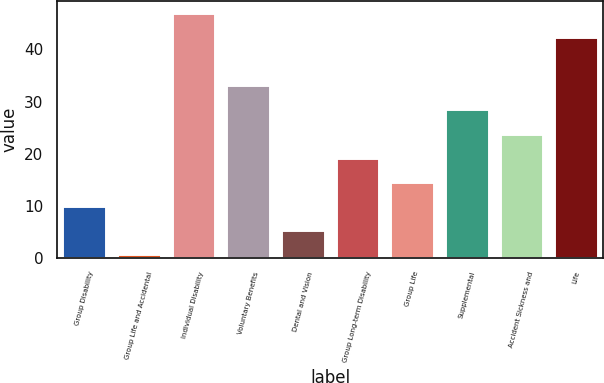Convert chart to OTSL. <chart><loc_0><loc_0><loc_500><loc_500><bar_chart><fcel>Group Disability<fcel>Group Life and Accidental<fcel>Individual Disability<fcel>Voluntary Benefits<fcel>Dental and Vision<fcel>Group Long-term Disability<fcel>Group Life<fcel>Supplemental<fcel>Accident Sickness and<fcel>Life<nl><fcel>9.96<fcel>0.7<fcel>47<fcel>33.11<fcel>5.33<fcel>19.22<fcel>14.59<fcel>28.48<fcel>23.85<fcel>42.37<nl></chart> 